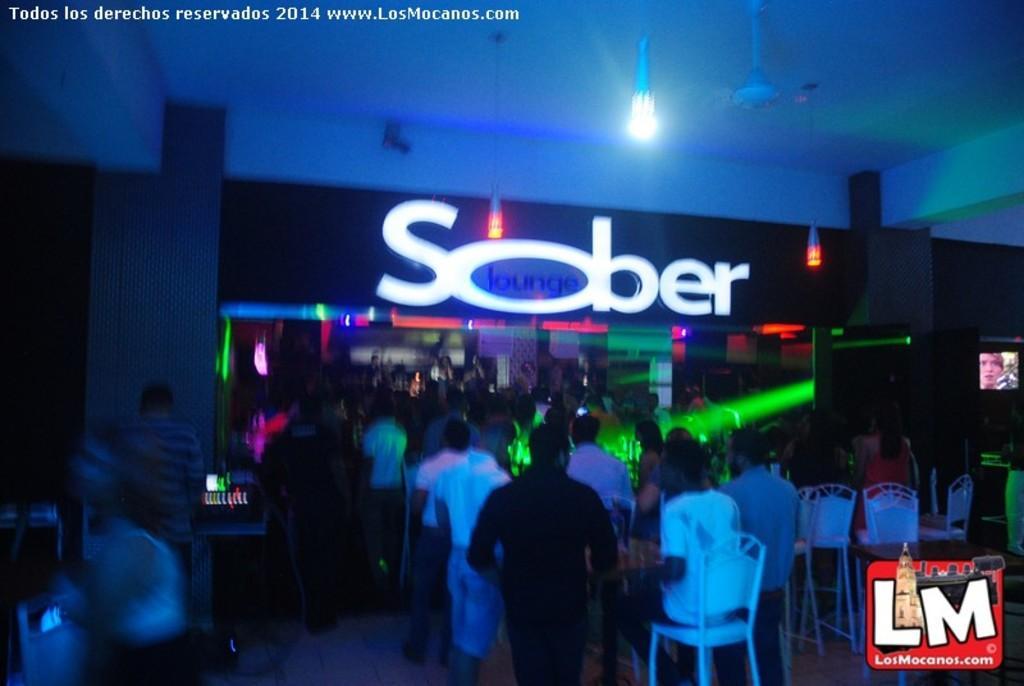In one or two sentences, can you explain what this image depicts? In this image, we can see an inside view of a building. There are persons wearing clothes. There is a person at the bottom of the image sitting on a chair. There is a table and some chairs in the bottom right of the image. There is a light and fan at the top of the image. There is a board in the middle of the image. There is a screen on the right side of the image. 